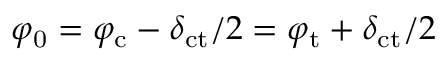Convert formula to latex. <formula><loc_0><loc_0><loc_500><loc_500>\varphi _ { 0 } = \varphi _ { c } - \delta _ { c t } / 2 = \varphi _ { t } + \delta _ { c t } / 2</formula> 